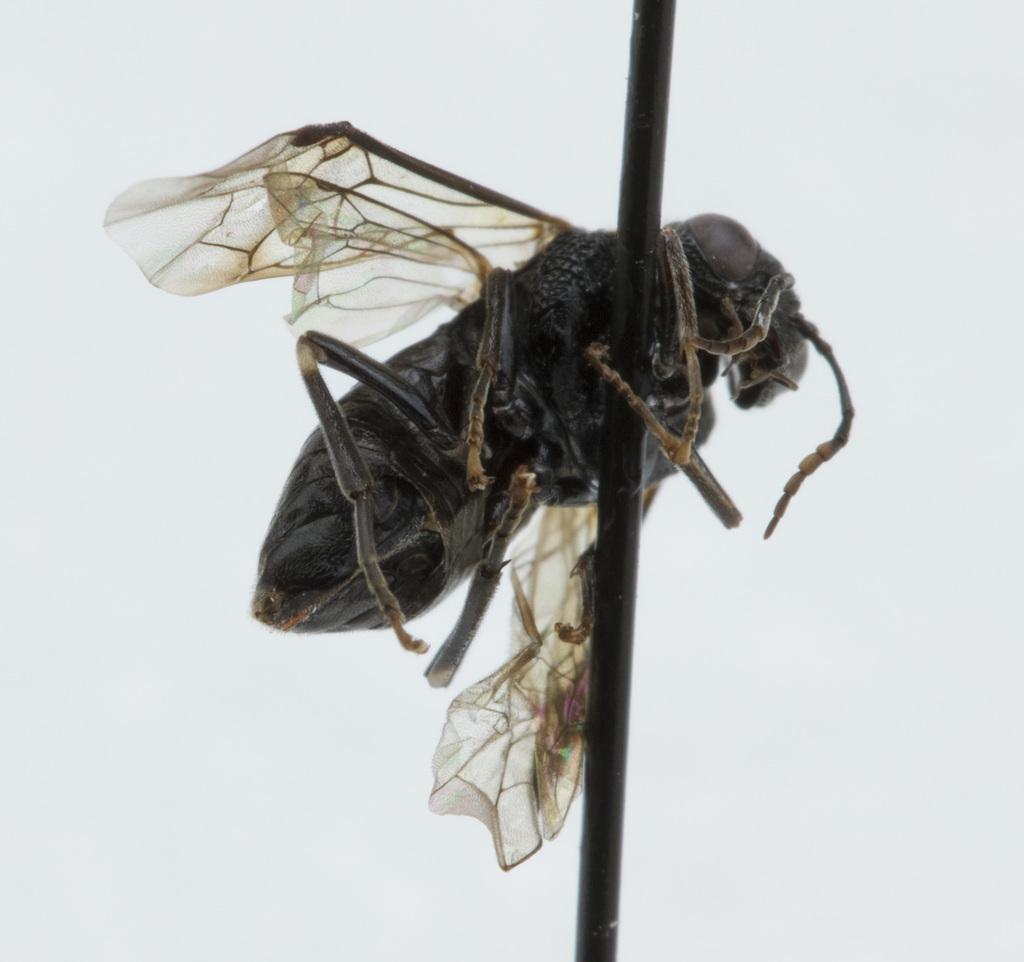Describe this image in one or two sentences. In this picture we can see a house fly on a pole and in the background it is white color. 